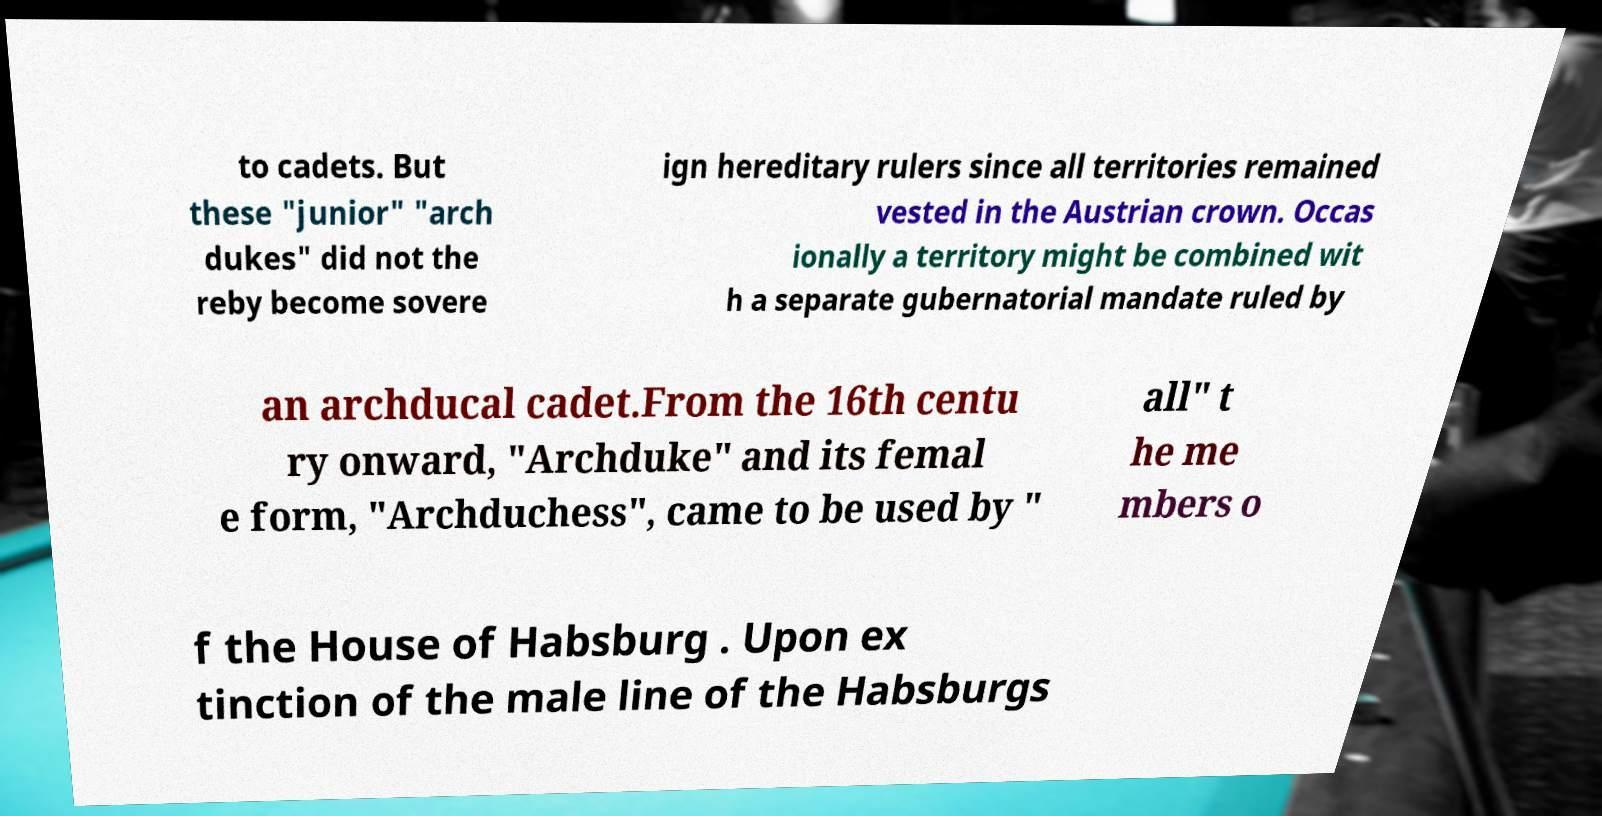Please read and relay the text visible in this image. What does it say? to cadets. But these "junior" "arch dukes" did not the reby become sovere ign hereditary rulers since all territories remained vested in the Austrian crown. Occas ionally a territory might be combined wit h a separate gubernatorial mandate ruled by an archducal cadet.From the 16th centu ry onward, "Archduke" and its femal e form, "Archduchess", came to be used by " all" t he me mbers o f the House of Habsburg . Upon ex tinction of the male line of the Habsburgs 